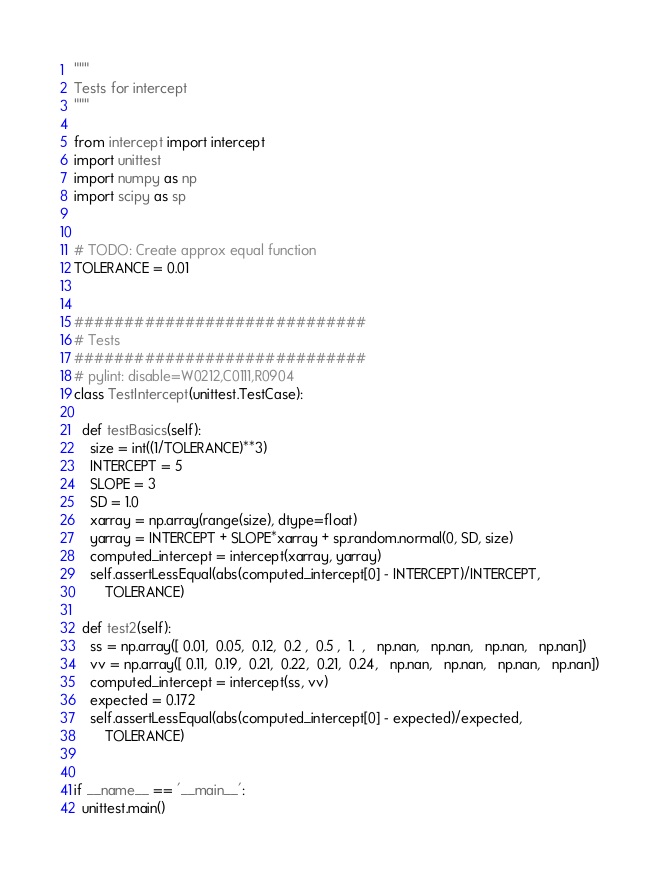Convert code to text. <code><loc_0><loc_0><loc_500><loc_500><_Python_>"""
Tests for intercept
"""

from intercept import intercept
import unittest
import numpy as np
import scipy as sp


# TODO: Create approx equal function
TOLERANCE = 0.01


#############################
# Tests
#############################
# pylint: disable=W0212,C0111,R0904
class TestIntercept(unittest.TestCase):

  def testBasics(self):
    size = int((1/TOLERANCE)**3)
    INTERCEPT = 5
    SLOPE = 3
    SD = 1.0
    xarray = np.array(range(size), dtype=float)
    yarray = INTERCEPT + SLOPE*xarray + sp.random.normal(0, SD, size)
    computed_intercept = intercept(xarray, yarray)
    self.assertLessEqual(abs(computed_intercept[0] - INTERCEPT)/INTERCEPT,
        TOLERANCE)

  def test2(self):
    ss = np.array([ 0.01,  0.05,  0.12,  0.2 ,  0.5 ,  1.  ,   np.nan,   np.nan,   np.nan,   np.nan])
    vv = np.array([ 0.11,  0.19,  0.21,  0.22,  0.21,  0.24,   np.nan,   np.nan,   np.nan,   np.nan])
    computed_intercept = intercept(ss, vv)
    expected = 0.172
    self.assertLessEqual(abs(computed_intercept[0] - expected)/expected,
        TOLERANCE)


if __name__ == '__main__':
  unittest.main()
</code> 